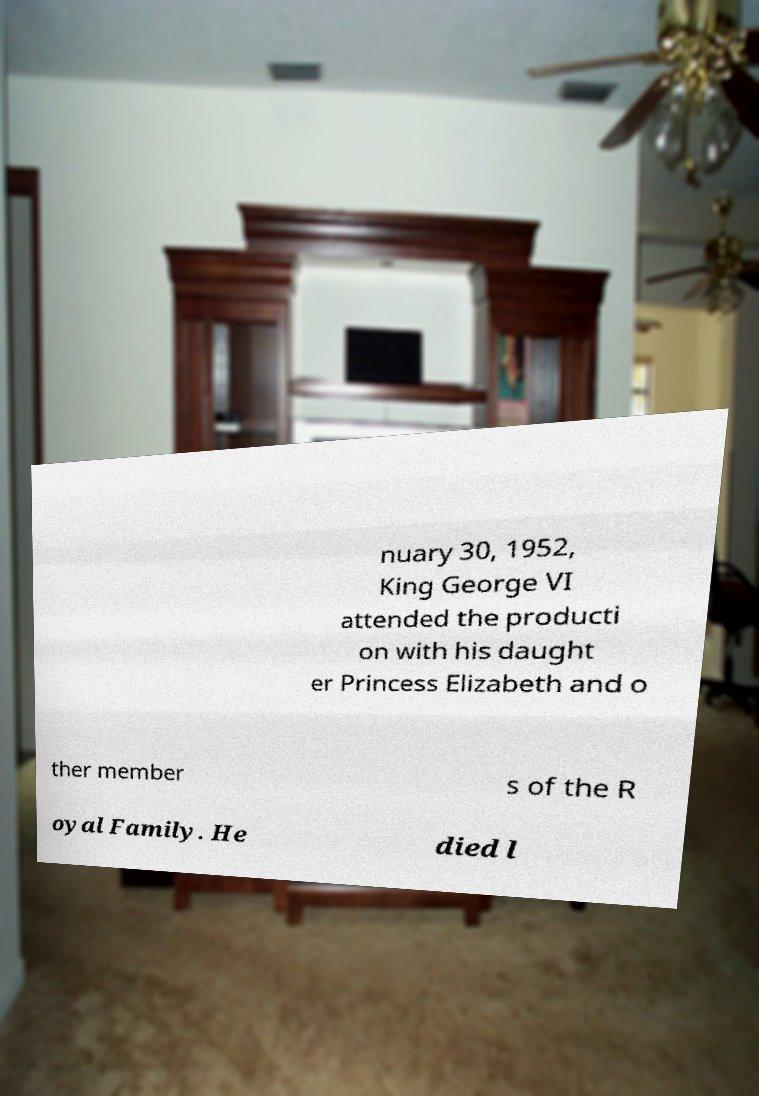Please read and relay the text visible in this image. What does it say? nuary 30, 1952, King George VI attended the producti on with his daught er Princess Elizabeth and o ther member s of the R oyal Family. He died l 